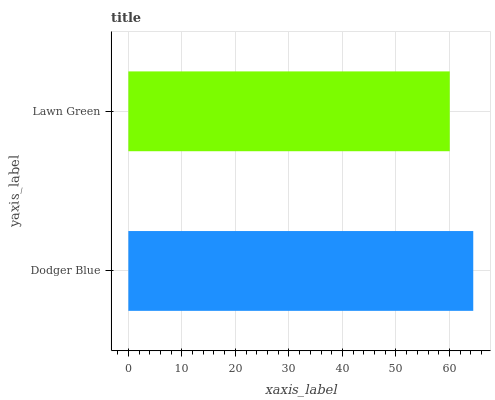Is Lawn Green the minimum?
Answer yes or no. Yes. Is Dodger Blue the maximum?
Answer yes or no. Yes. Is Lawn Green the maximum?
Answer yes or no. No. Is Dodger Blue greater than Lawn Green?
Answer yes or no. Yes. Is Lawn Green less than Dodger Blue?
Answer yes or no. Yes. Is Lawn Green greater than Dodger Blue?
Answer yes or no. No. Is Dodger Blue less than Lawn Green?
Answer yes or no. No. Is Dodger Blue the high median?
Answer yes or no. Yes. Is Lawn Green the low median?
Answer yes or no. Yes. Is Lawn Green the high median?
Answer yes or no. No. Is Dodger Blue the low median?
Answer yes or no. No. 